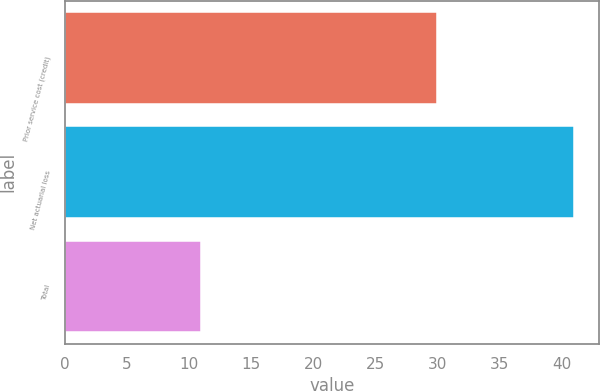Convert chart. <chart><loc_0><loc_0><loc_500><loc_500><bar_chart><fcel>Prior service cost (credit)<fcel>Net actuarial loss<fcel>Total<nl><fcel>30<fcel>41<fcel>11<nl></chart> 